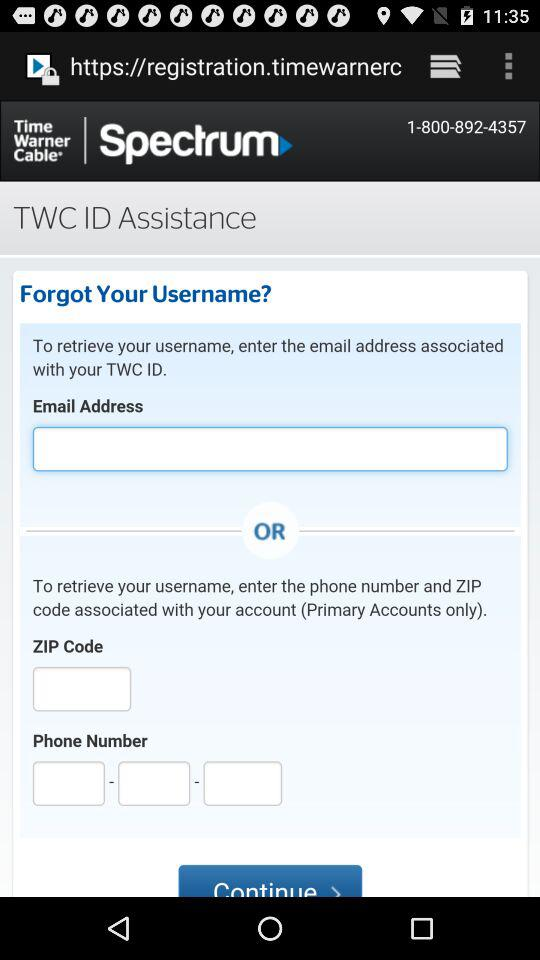What is the given phone number? The given phone number is 1-800-892-4357. 